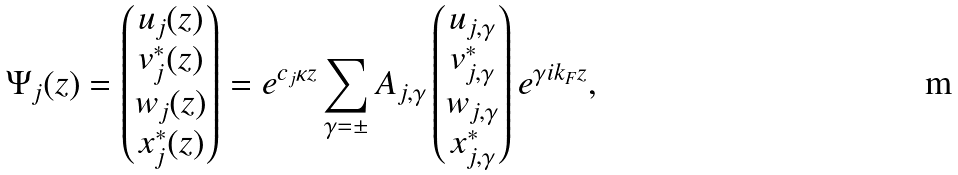Convert formula to latex. <formula><loc_0><loc_0><loc_500><loc_500>\Psi _ { j } ( z ) = \begin{pmatrix} u _ { j } ( z ) \\ v ^ { \ast } _ { j } ( z ) \\ w _ { j } ( z ) \\ x ^ { \ast } _ { j } ( z ) \end{pmatrix} = e ^ { c _ { j } \kappa z } \sum _ { \gamma = \pm } A _ { j , \gamma } \begin{pmatrix} u _ { j , \gamma } \\ v ^ { \ast } _ { j , \gamma } \\ w _ { j , \gamma } \\ x _ { j , \gamma } ^ { \ast } \end{pmatrix} e ^ { \gamma i k _ { F } z } ,</formula> 